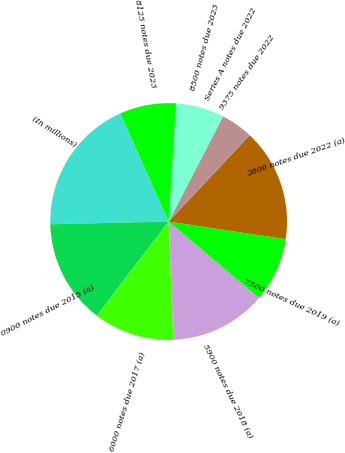<chart> <loc_0><loc_0><loc_500><loc_500><pie_chart><fcel>(In millions)<fcel>0900 notes due 2015 (a)<fcel>6000 notes due 2017 (a)<fcel>5900 notes due 2018 (a)<fcel>7500 notes due 2019 (a)<fcel>2800 notes due 2022 (a)<fcel>9375 notes due 2022<fcel>Series A notes due 2022<fcel>8500 notes due 2023<fcel>8125 notes due 2023<nl><fcel>18.68%<fcel>14.28%<fcel>10.99%<fcel>13.19%<fcel>8.79%<fcel>15.38%<fcel>4.4%<fcel>0.01%<fcel>6.6%<fcel>7.69%<nl></chart> 